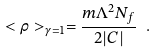<formula> <loc_0><loc_0><loc_500><loc_500>< \rho > _ { \gamma = 1 } = \frac { m \Lambda ^ { 2 } N _ { f } } { 2 | C | } \ .</formula> 